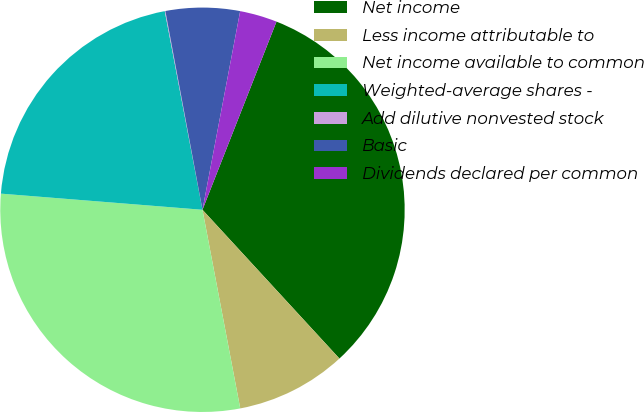Convert chart to OTSL. <chart><loc_0><loc_0><loc_500><loc_500><pie_chart><fcel>Net income<fcel>Less income attributable to<fcel>Net income available to common<fcel>Weighted-average shares -<fcel>Add dilutive nonvested stock<fcel>Basic<fcel>Dividends declared per common<nl><fcel>32.19%<fcel>8.85%<fcel>29.26%<fcel>20.74%<fcel>0.05%<fcel>5.92%<fcel>2.98%<nl></chart> 